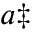<formula> <loc_0><loc_0><loc_500><loc_500>^ { a \ddag }</formula> 